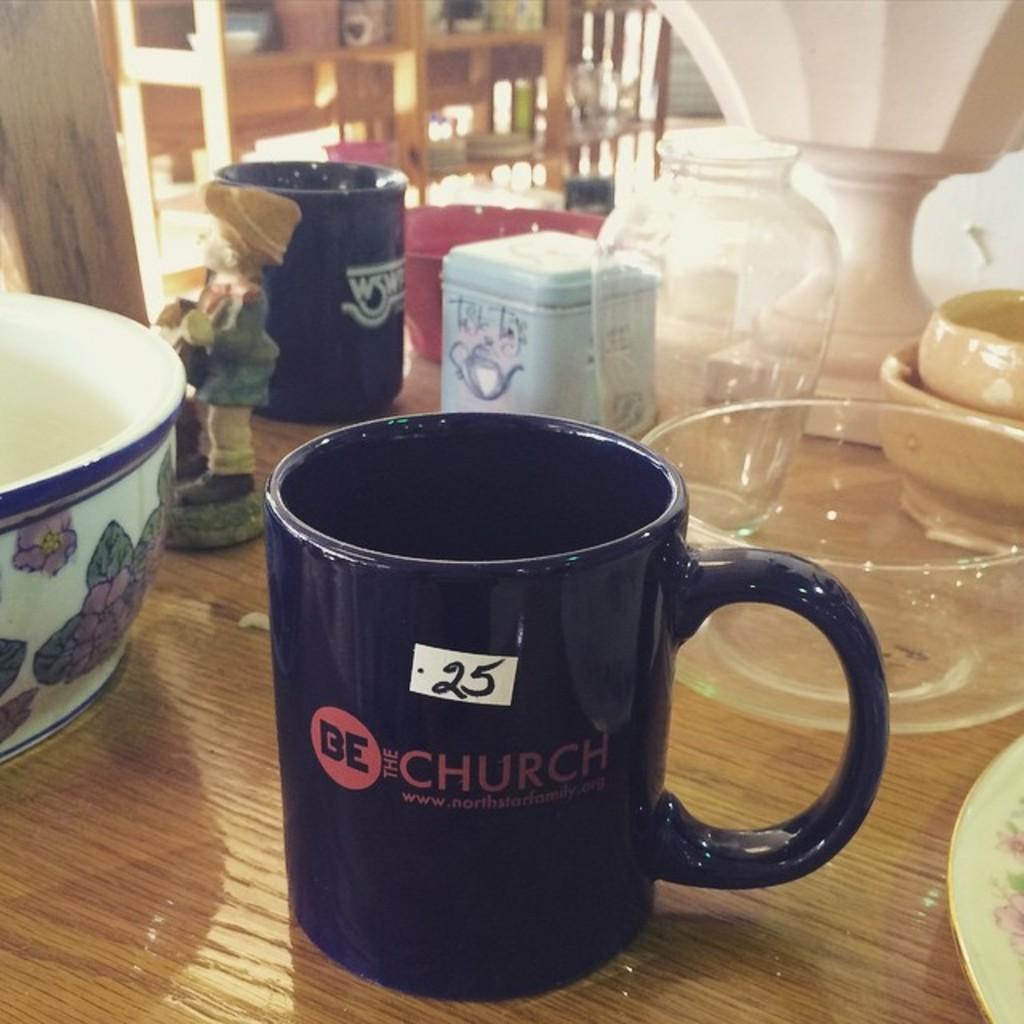What organization is shown on this mug?
Make the answer very short. Be the church. What number is on the black mug?
Your answer should be very brief. 25. 